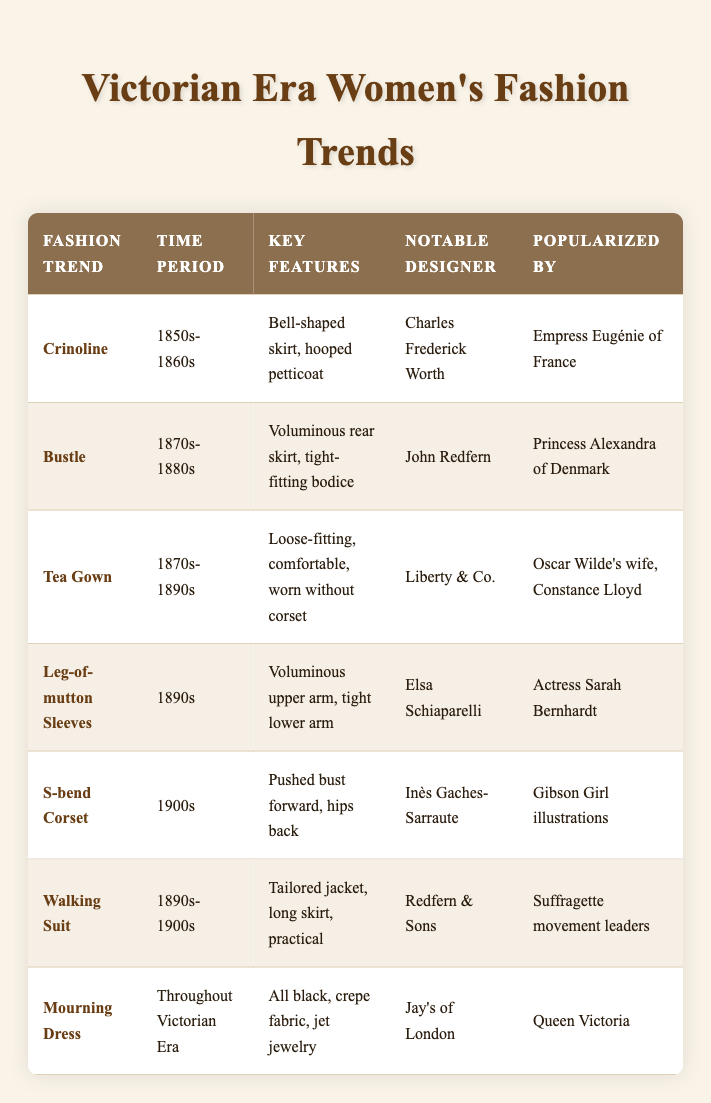What fashion trend was popularized by Empress Eugénie of France? By looking in the "Popularized By" column for Empress Eugénie of France, we find that she is associated with the "Crinoline" trend, which is documented in the table.
Answer: Crinoline Which fashion trend featured voluminous rear skirts? The table identifies the "Bustle" trend as having a voluminous rear skirt, with the key features described.
Answer: Bustle True or False: The "Walking Suit" was popularized by Queen Victoria. Checking the "Popularized By" column for "Walking Suit", it shows that it was popularized by suffragette movement leaders, not Queen Victoria, making the statement false.
Answer: False What were the key features of the "Leg-of-mutton Sleeves"? The table lists the key features of "Leg-of-mutton Sleeves" as "Voluminous upper arm, tight lower arm", found in the “Key Features” column.
Answer: Voluminous upper arm, tight lower arm Which two fashion trends share the time period of the 1890s? Upon examining the time periods, both "Tea Gown" (1870s-1890s) and "Leg-of-mutton Sleeves" (1890s) fit within the 1890s. Therefore, they can be combined from the respective rows.
Answer: Tea Gown, Leg-of-mutton Sleeves What notable designer is associated with the "S-bend Corset"? Looking in the "Notable Designer" column, the designer for the "S-bend Corset" is Inès Gaches-Sarraute, which answers the question directly.
Answer: Inès Gaches-Sarraute Which fashion trend had all black as a key feature? The table describes the "Mourning Dress" as featuring all black, crepe fabric, which points directly to the relevant row where this detail is noted.
Answer: Mourning Dress Identify the fashion trend that was worn without a corset. From the "Key Features" of "Tea Gown", it is specifically mentioned that it was comfortable and worn without a corset as indicated in the table's description.
Answer: Tea Gown Which notable designer is associated with both the "Bustle" and "Walking Suit"? By scanning the "Notable Designer" column, John Redfern is linked to the "Bustle" trend, whereas Redfern & Sons are associated with the "Walking Suit", indicating they are related but not the same. Therefore, there is no single designer connecting both.
Answer: None 